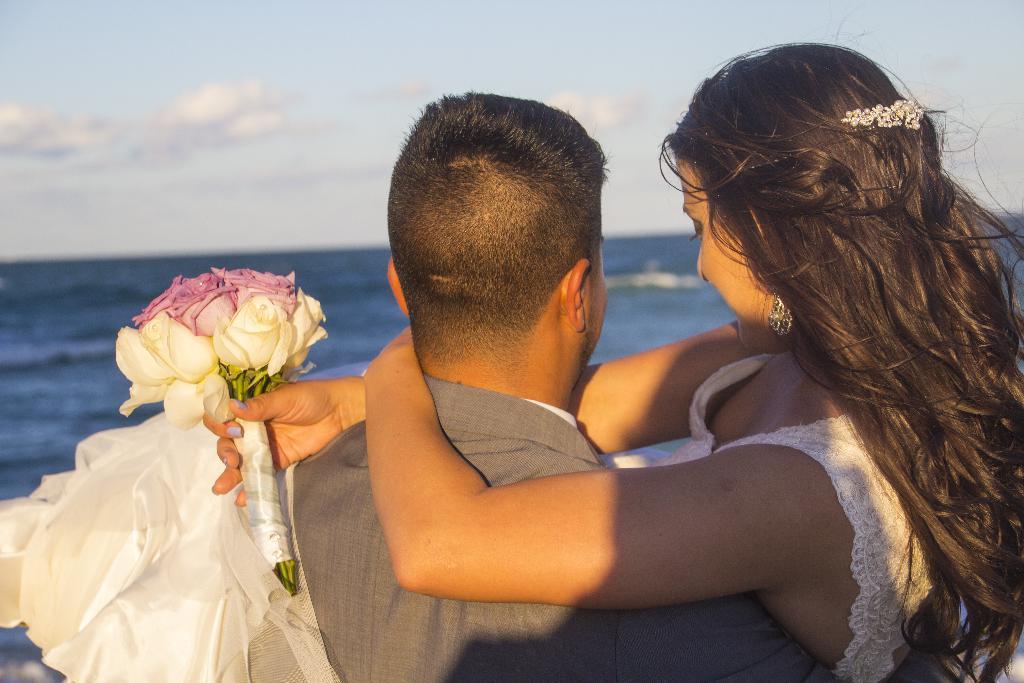Please provide a concise description of this image. In this image I can see two persons. The person in front is lifting the other person and the person is wearing gray blazer and the other person is wearing white color dress holding few flowers. Background I can see water in blue color, sky in blue and white color. 